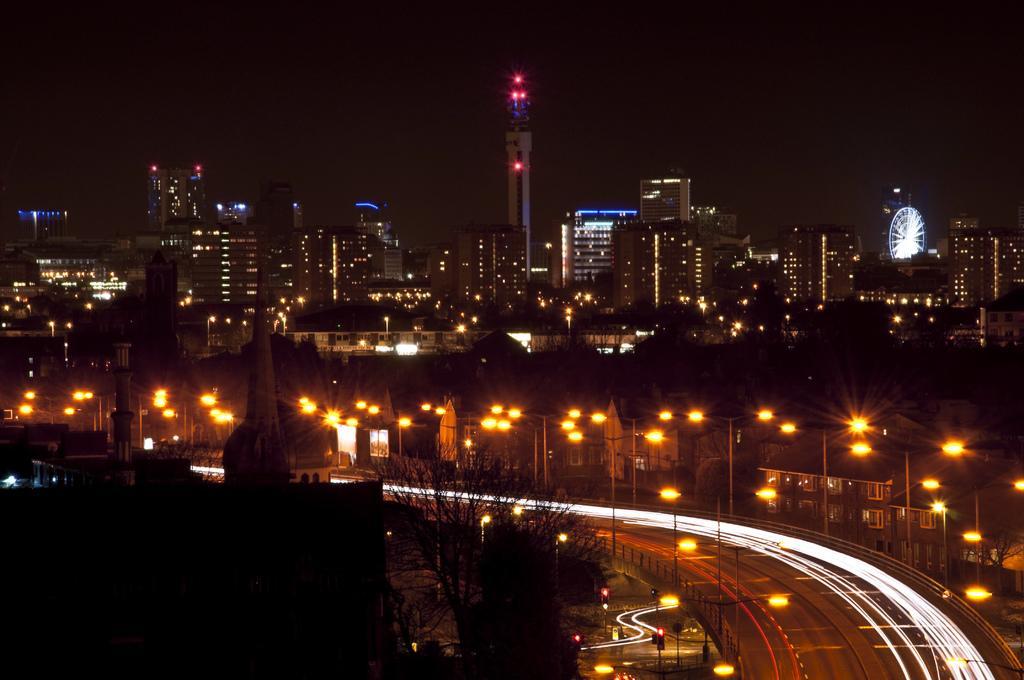Could you give a brief overview of what you see in this image? In this picture we can see a road, electric poles with lights, traffic signals, buildings, trees and in the background we can see it is dark. 